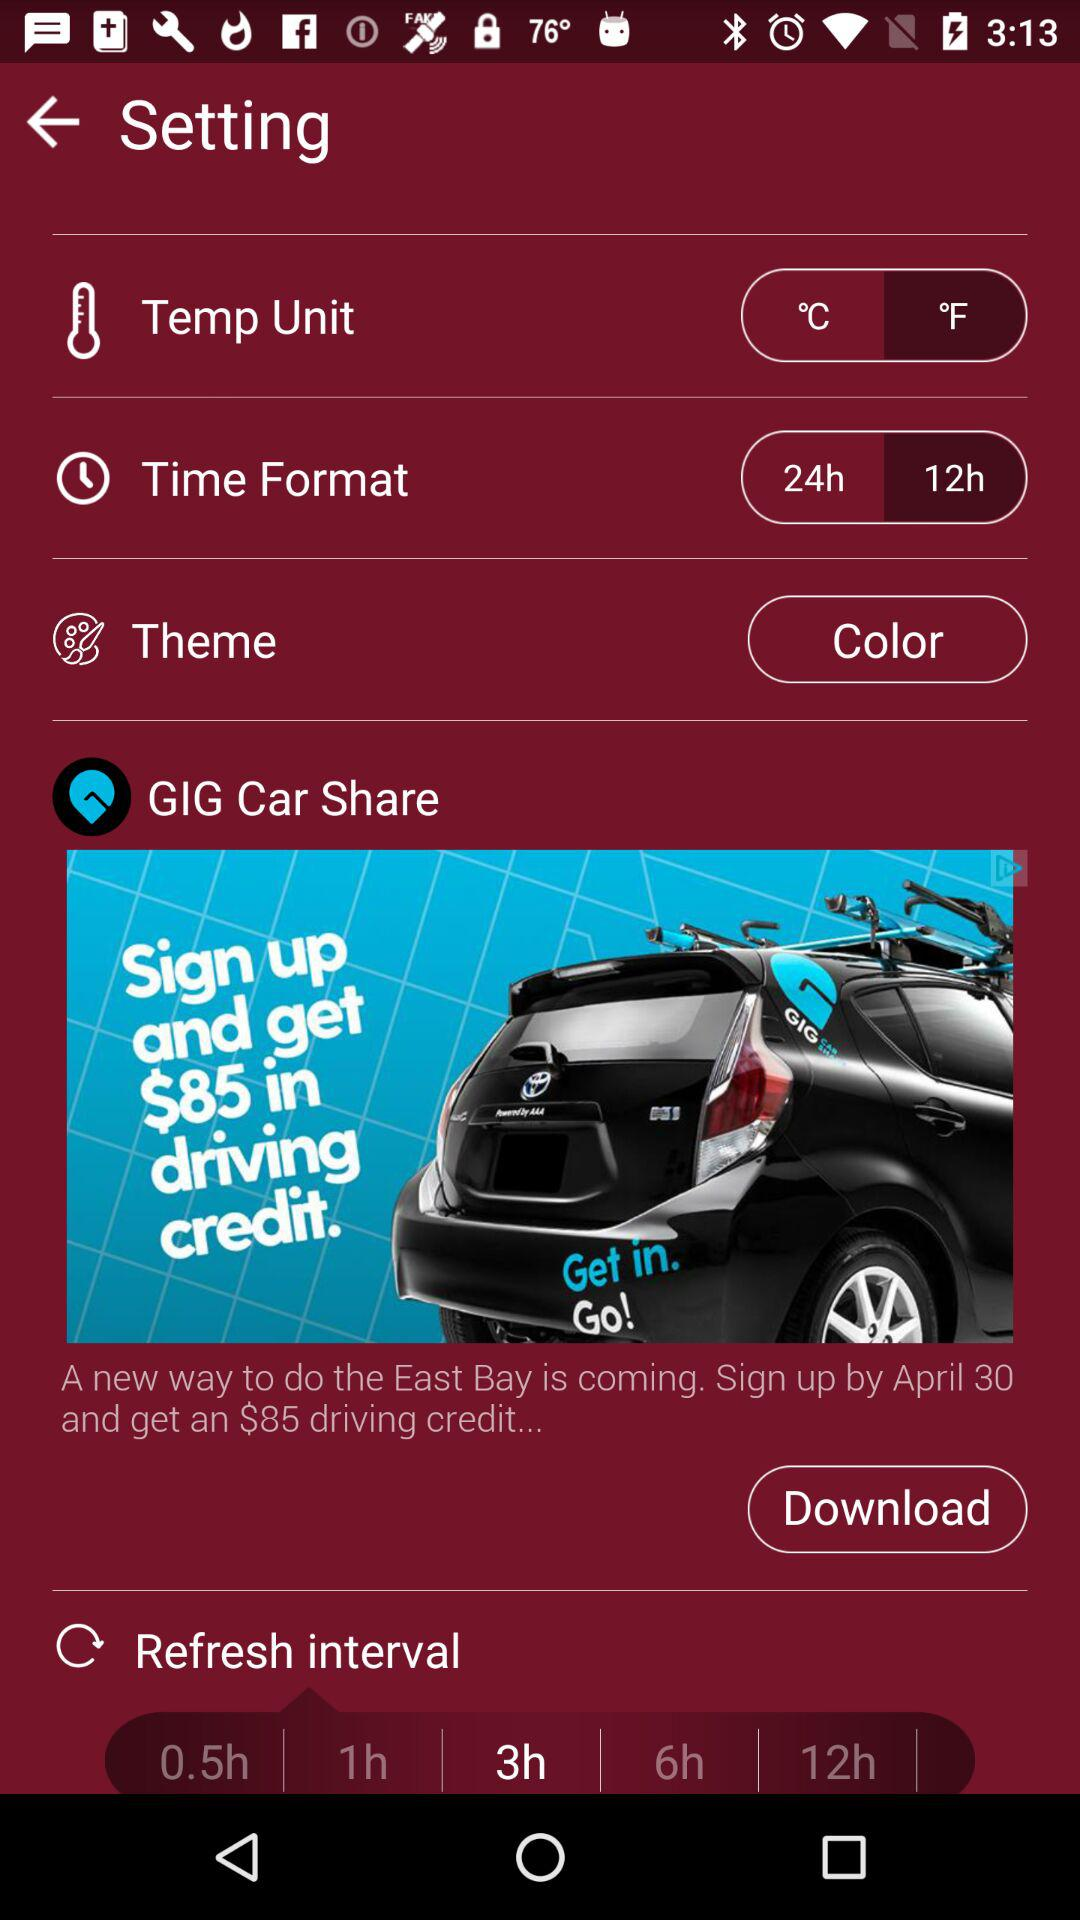What is the selected theme? The selected theme is "Color". 